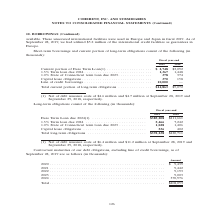According to Coherent's financial document, What does the Current portion of Euro Term Loan consist of? (1) Net of debt issuance costs of $4.6 million and $4.7 million at September 28, 2019 and September 29, 2018, respectively.. The document states: "(1) Net of debt issuance costs of $4.6 million and $4.7 million at September 28, 2019 and September 29, 2018, respectively...." Also, What was the amount of Line of credit borrowings in 2019? According to the financial document, 10,000 (in thousands). The relevant text states: "obligations . 370 158 Line of credit borrowings . 10,000 —..." Also, In which years was the Total current portion of long-term obligations calculated? The document shows two values: 2019 and 2018. From the document: "Fiscal year-end 2019 2018 Fiscal year-end 2019 2018..." Additionally, In which year was the 1.0% State of Connecticut term loan due 2023 larger? According to the financial document, 2019. The relevant text states: "Fiscal year-end 2019 2018..." Also, can you calculate: What was the change in Capital lease obligations from 2018 to 2019? Based on the calculation: 370-158, the result is 212 (in thousands). This is based on the information: "an due 2023 . 378 374 Capital lease obligations . 370 158 Line of credit borrowings . 10,000 — ue 2023 . 378 374 Capital lease obligations . 370 158 Line of credit borrowings . 10,000 —..." The key data points involved are: 158, 370. Also, can you calculate: What was the percentage change in Capital lease obligations from 2018 to 2019? To answer this question, I need to perform calculations using the financial data. The calculation is: (370-158)/158, which equals 134.18 (percentage). This is based on the information: "an due 2023 . 378 374 Capital lease obligations . 370 158 Line of credit borrowings . 10,000 — ue 2023 . 378 374 Capital lease obligations . 370 158 Line of credit borrowings . 10,000 —..." The key data points involved are: 158, 370. 